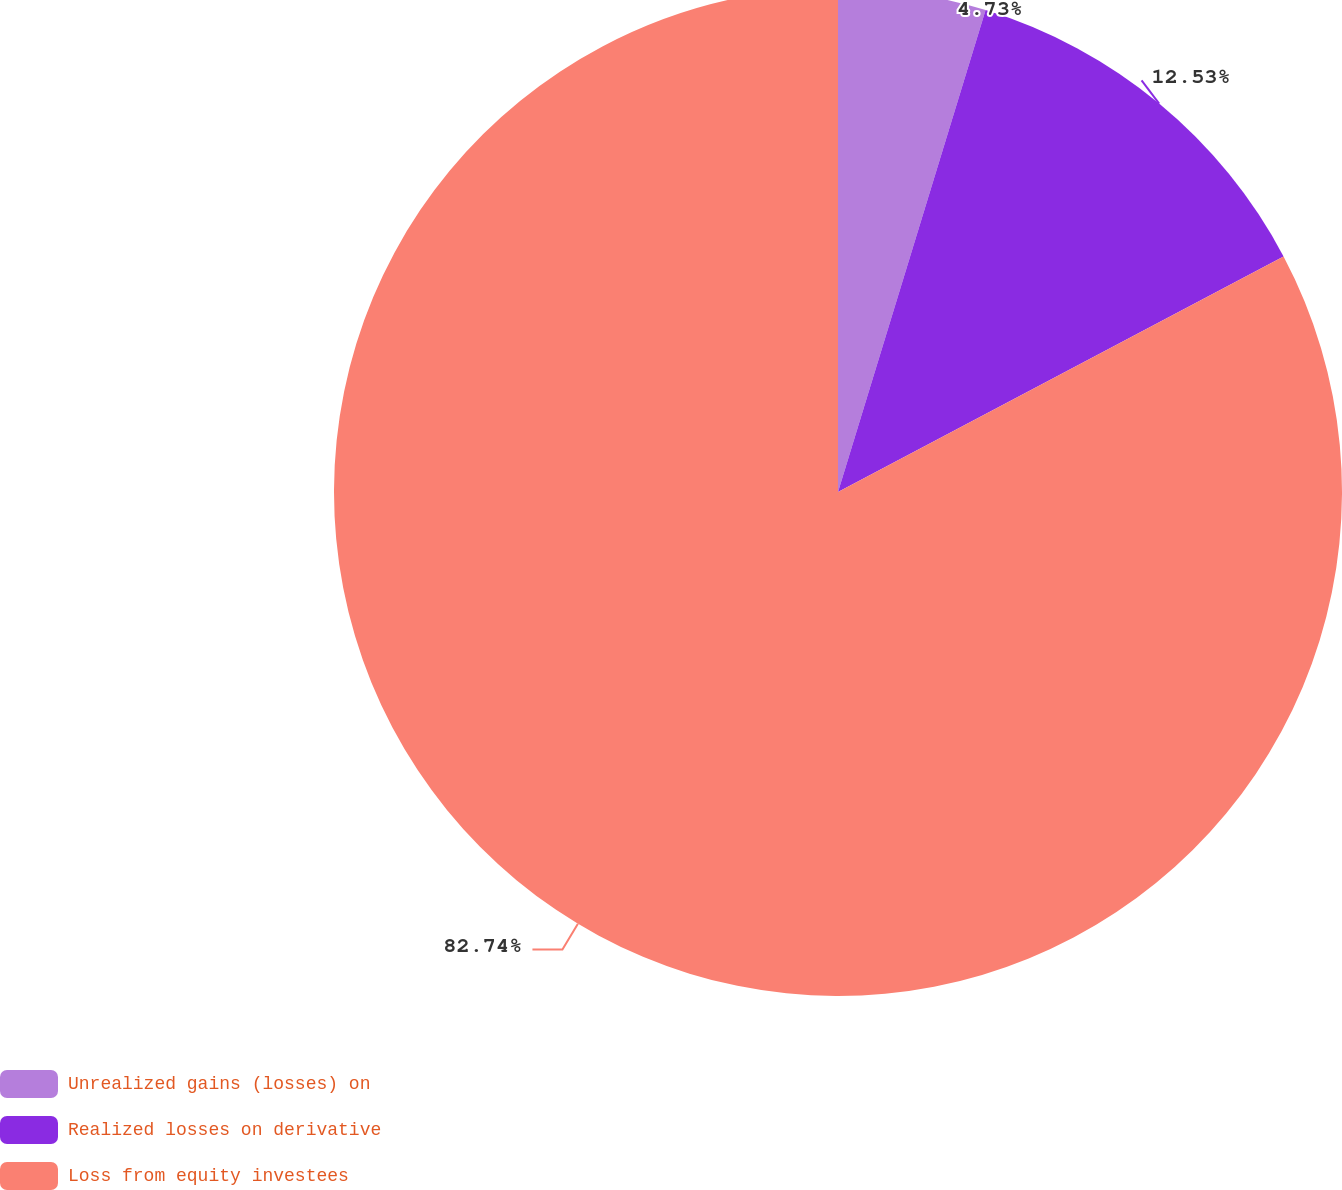<chart> <loc_0><loc_0><loc_500><loc_500><pie_chart><fcel>Unrealized gains (losses) on<fcel>Realized losses on derivative<fcel>Loss from equity investees<nl><fcel>4.73%<fcel>12.53%<fcel>82.74%<nl></chart> 